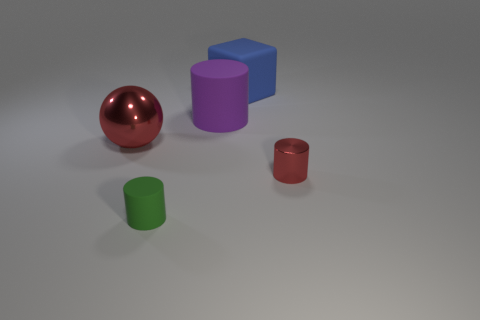Subtract all purple cylinders. How many cylinders are left? 2 Subtract all large cylinders. How many cylinders are left? 2 Add 5 purple cylinders. How many objects exist? 10 Subtract all cylinders. How many objects are left? 2 Subtract 2 cylinders. How many cylinders are left? 1 Subtract all green cylinders. Subtract all purple balls. How many cylinders are left? 2 Subtract all green spheres. How many purple cylinders are left? 1 Subtract all tiny red shiny cylinders. Subtract all large metallic spheres. How many objects are left? 3 Add 5 metallic cylinders. How many metallic cylinders are left? 6 Add 3 big purple rubber things. How many big purple rubber things exist? 4 